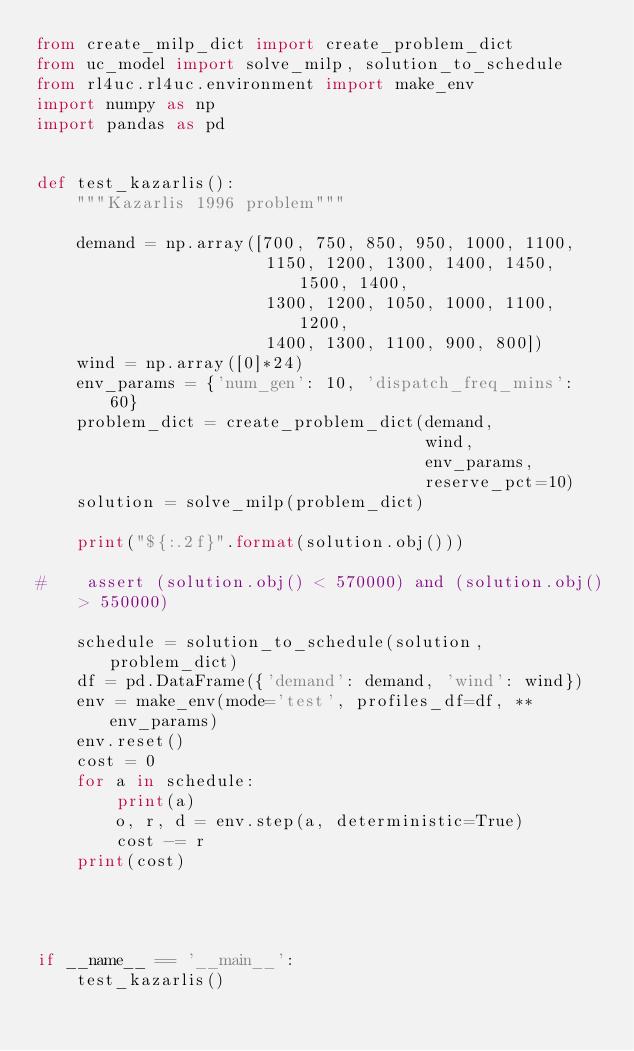<code> <loc_0><loc_0><loc_500><loc_500><_Python_>from create_milp_dict import create_problem_dict
from uc_model import solve_milp, solution_to_schedule
from rl4uc.rl4uc.environment import make_env
import numpy as np
import pandas as pd


def test_kazarlis():
    """Kazarlis 1996 problem"""

    demand = np.array([700, 750, 850, 950, 1000, 1100,
                       1150, 1200, 1300, 1400, 1450, 1500, 1400,
                       1300, 1200, 1050, 1000, 1100, 1200,
                       1400, 1300, 1100, 900, 800])
    wind = np.array([0]*24)
    env_params = {'num_gen': 10, 'dispatch_freq_mins': 60}
    problem_dict = create_problem_dict(demand,
                                       wind,
                                       env_params,
                                       reserve_pct=10)
    solution = solve_milp(problem_dict)

    print("${:.2f}".format(solution.obj()))

#    assert (solution.obj() < 570000) and (solution.obj() > 550000)

    schedule = solution_to_schedule(solution, problem_dict)
    df = pd.DataFrame({'demand': demand, 'wind': wind})
    env = make_env(mode='test', profiles_df=df, **env_params)
    env.reset()
    cost = 0
    for a in schedule:
        print(a)
        o, r, d = env.step(a, deterministic=True)
        cost -= r
    print(cost)
        
    


if __name__ == '__main__':
    test_kazarlis()

    
</code> 